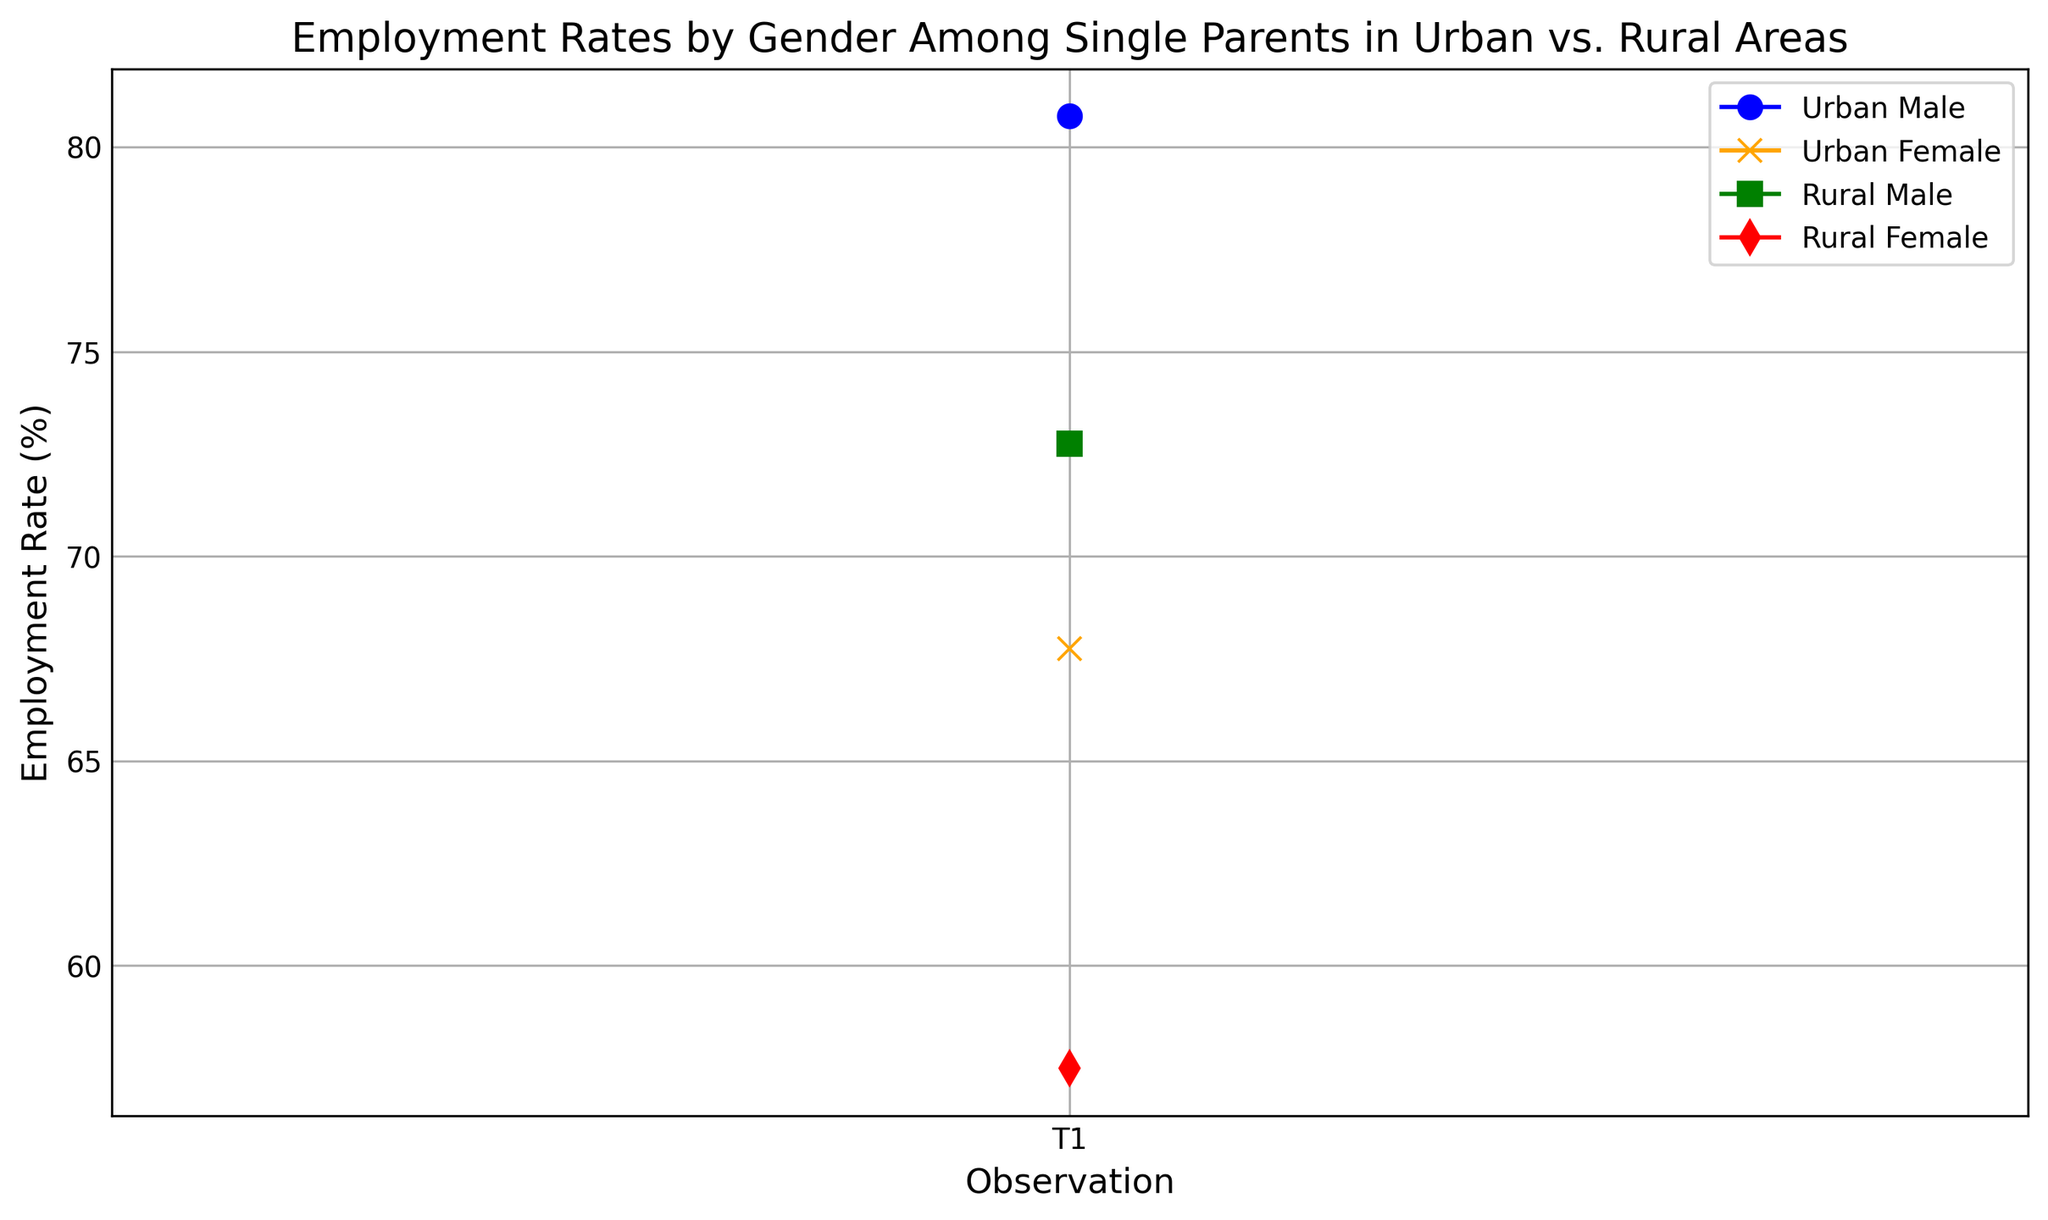Which group has the highest employment rate in the most recent observation? The most recent observation is the last data point, and by looking at the heights of the lines representing each group, 'Urban Male' has the highest employment rate.
Answer: Urban Male What is the difference in employment rates between Urban Males and Urban Females across the observations? For each observation point, subtract the Urban Female employment rate from the Urban Male employment rate:
(83-70) + (82-69) + (80-67) + (78-65) = 13 + 13 + 13 + 13 = 52
Answer: 52 Which group shows the lowest employment rate in rural areas consistently? By referring to the line colors representing Rural groups, 'Rural Female' is consistently lower than 'Rural Male' in all observations.
Answer: Rural Female How does the employment rate of Urban Females change over time? The line for Urban Female, marked with x's and colored orange, shows an increasing trend from 65 to 70 over the observations.
Answer: Increases Which group has the smallest employment rate change over the timeframe? By looking at the change in each group's line, 'Urban Male' changes from 78 to 83, 'Urban Female' from 65 to 70, 'Rural Male' from 70 to 75, and 'Rural Female' from 55 to 60. Urban Male has the smallest change of 5.
Answer: Urban Male Between Rural Males and Urban Females, who has a higher employment rate in the first observation? For the first data point, the employment rate for Rural Male is 70 and for Urban Female is 65. Hence, Rural Male is higher.
Answer: Rural Male What is the average employment rate of Rural Males across the observations? Adding the employment rates of Rural Males (70 + 72 + 74 + 75) and dividing by 4: (70 + 72 + 74 + 75) / 4 = 72.75
Answer: 72.75 What is the combined employment rate of Urban Males and Females in the second observation? For the second data point, add Urban Male (80) and Urban Female (67) rates: 80 + 67 = 147
Answer: 147 Is there any point where Urban Female employment rates surpassed Rural Male employment rates? Visual examination shows that the Urban Female line (orange) is always below the Rural Male line (green) at all observation points.
Answer: No Which color represents the Rural Female group in the plot? The Rural Female group is represented by the red line with diamond markers (d).
Answer: Red 